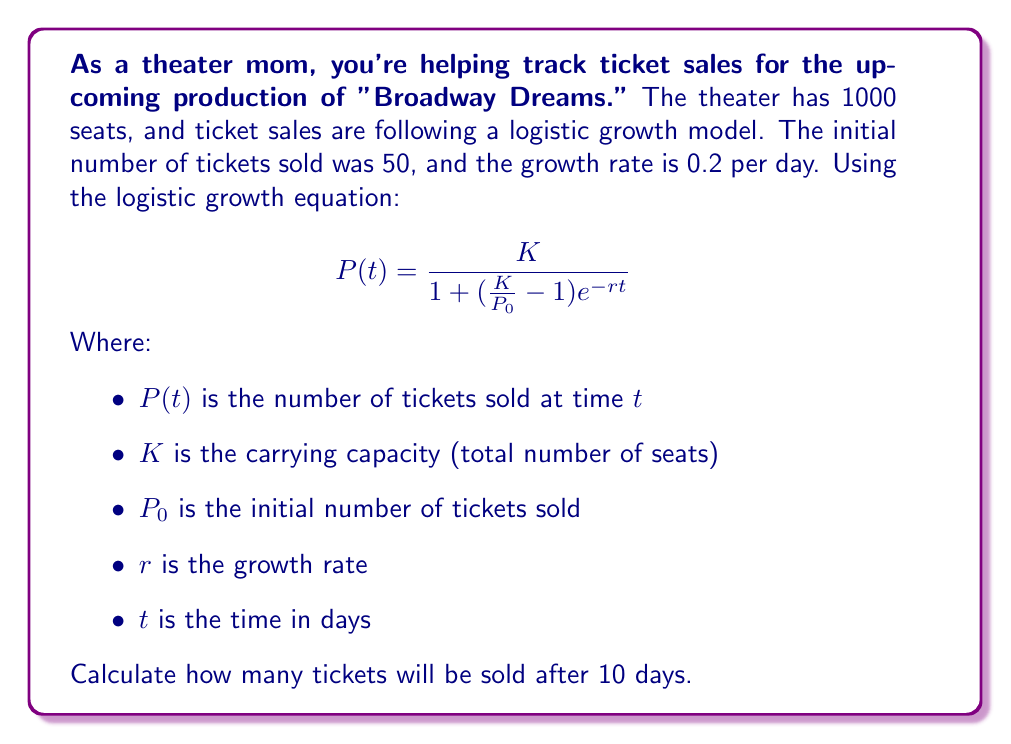Could you help me with this problem? Let's approach this step-by-step:

1) We are given:
   $K = 1000$ (total seats)
   $P_0 = 50$ (initial tickets sold)
   $r = 0.2$ (growth rate per day)
   $t = 10$ (days)

2) Let's substitute these values into the logistic growth equation:

   $$P(10) = \frac{1000}{1 + (\frac{1000}{50} - 1)e^{-0.2(10)}}$$

3) Simplify the fraction inside the parentheses:
   $$P(10) = \frac{1000}{1 + (20 - 1)e^{-2}}$$

4) Simplify further:
   $$P(10) = \frac{1000}{1 + 19e^{-2}}$$

5) Calculate $e^{-2}$:
   $e^{-2} \approx 0.1353$

6) Multiply:
   $$P(10) = \frac{1000}{1 + 19(0.1353)} = \frac{1000}{1 + 2.5707}$$

7) Add in the denominator:
   $$P(10) = \frac{1000}{3.5707}$$

8) Divide:
   $$P(10) \approx 279.78$$

9) Since we can't sell a fraction of a ticket, we round down to the nearest whole number.
Answer: 279 tickets 